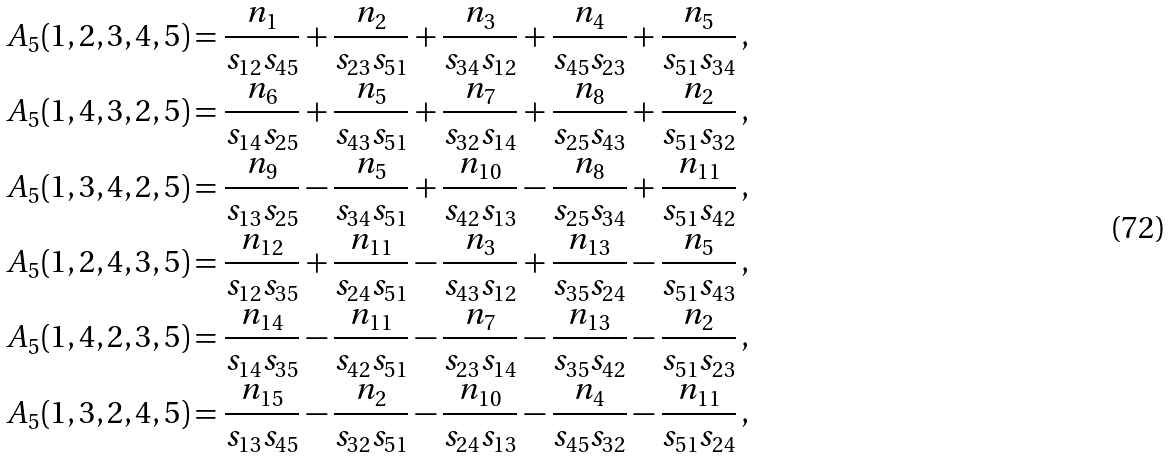<formula> <loc_0><loc_0><loc_500><loc_500>A _ { 5 } ( 1 , 2 , 3 , 4 , 5 ) & = \frac { n _ { 1 } } { s _ { 1 2 } s _ { 4 5 } } + \frac { n _ { 2 } } { s _ { 2 3 } s _ { 5 1 } } + \frac { n _ { 3 } } { s _ { 3 4 } s _ { 1 2 } } + \frac { n _ { 4 } } { s _ { 4 5 } s _ { 2 3 } } + \frac { n _ { 5 } } { s _ { 5 1 } s _ { 3 4 } } \, , \\ A _ { 5 } ( 1 , 4 , 3 , 2 , 5 ) & = \frac { n _ { 6 } } { s _ { 1 4 } s _ { 2 5 } } + \frac { n _ { 5 } } { s _ { 4 3 } s _ { 5 1 } } + \frac { n _ { 7 } } { s _ { 3 2 } s _ { 1 4 } } + \frac { n _ { 8 } } { s _ { 2 5 } s _ { 4 3 } } + \frac { n _ { 2 } } { s _ { 5 1 } s _ { 3 2 } } \, , \\ A _ { 5 } ( 1 , 3 , 4 , 2 , 5 ) & = \frac { n _ { 9 } } { s _ { 1 3 } s _ { 2 5 } } - \frac { n _ { 5 } } { s _ { 3 4 } s _ { 5 1 } } + \frac { n _ { 1 0 } } { s _ { 4 2 } s _ { 1 3 } } - \frac { n _ { 8 } } { s _ { 2 5 } s _ { 3 4 } } + \frac { n _ { 1 1 } } { s _ { 5 1 } s _ { 4 2 } } \, , \\ A _ { 5 } ( 1 , 2 , 4 , 3 , 5 ) & = \frac { n _ { 1 2 } } { s _ { 1 2 } s _ { 3 5 } } + \frac { n _ { 1 1 } } { s _ { 2 4 } s _ { 5 1 } } - \frac { n _ { 3 } } { s _ { 4 3 } s _ { 1 2 } } + \frac { n _ { 1 3 } } { s _ { 3 5 } s _ { 2 4 } } - \frac { n _ { 5 } } { s _ { 5 1 } s _ { 4 3 } } \, , \\ A _ { 5 } ( 1 , 4 , 2 , 3 , 5 ) & = \frac { n _ { 1 4 } } { s _ { 1 4 } s _ { 3 5 } } - \frac { n _ { 1 1 } } { s _ { 4 2 } s _ { 5 1 } } - \frac { n _ { 7 } } { s _ { 2 3 } s _ { 1 4 } } - \frac { n _ { 1 3 } } { s _ { 3 5 } s _ { 4 2 } } - \frac { n _ { 2 } } { s _ { 5 1 } s _ { 2 3 } } \, , \\ A _ { 5 } ( 1 , 3 , 2 , 4 , 5 ) & = \frac { n _ { 1 5 } } { s _ { 1 3 } s _ { 4 5 } } - \frac { n _ { 2 } } { s _ { 3 2 } s _ { 5 1 } } - \frac { n _ { 1 0 } } { s _ { 2 4 } s _ { 1 3 } } - \frac { n _ { 4 } } { s _ { 4 5 } s _ { 3 2 } } - \frac { n _ { 1 1 } } { s _ { 5 1 } s _ { 2 4 } } \, , \\</formula> 